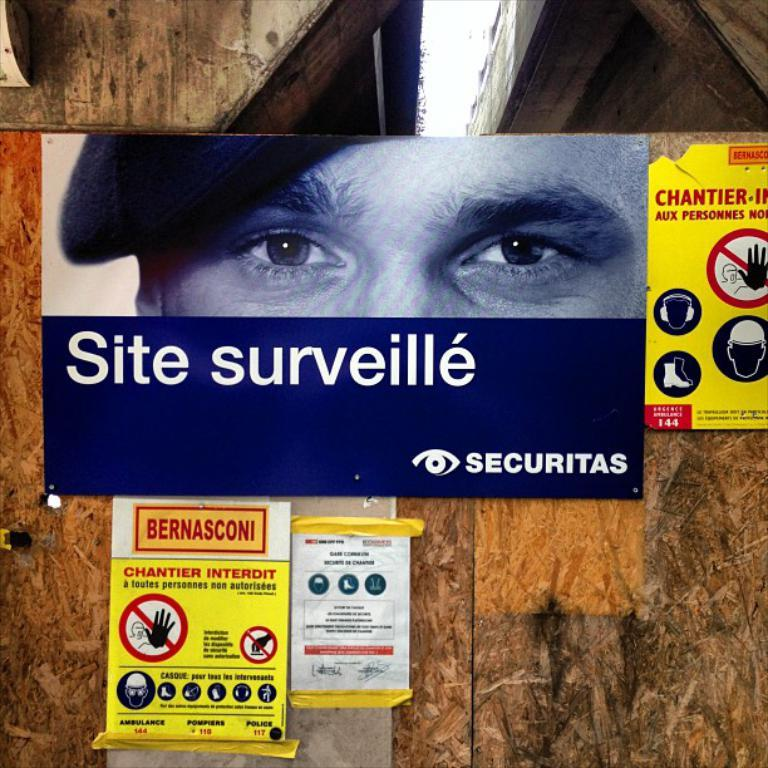What is on the wall in the image? There are posters on the wall in the image. What type of hair can be seen on the posters in the image? There is no hair visible on the posters in the image. 